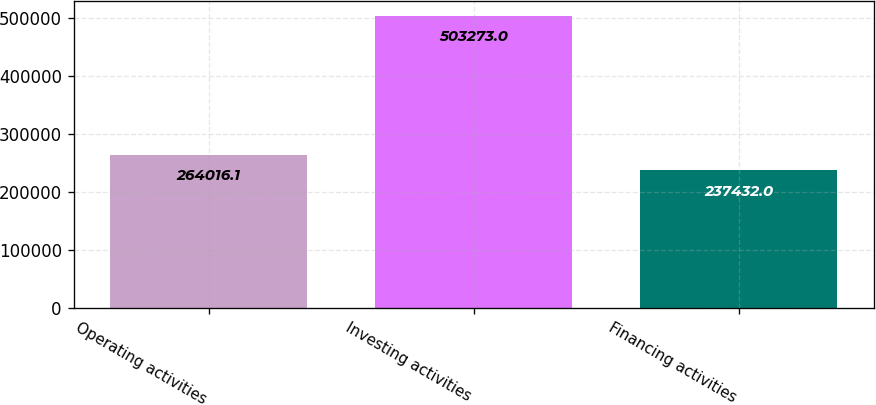Convert chart to OTSL. <chart><loc_0><loc_0><loc_500><loc_500><bar_chart><fcel>Operating activities<fcel>Investing activities<fcel>Financing activities<nl><fcel>264016<fcel>503273<fcel>237432<nl></chart> 